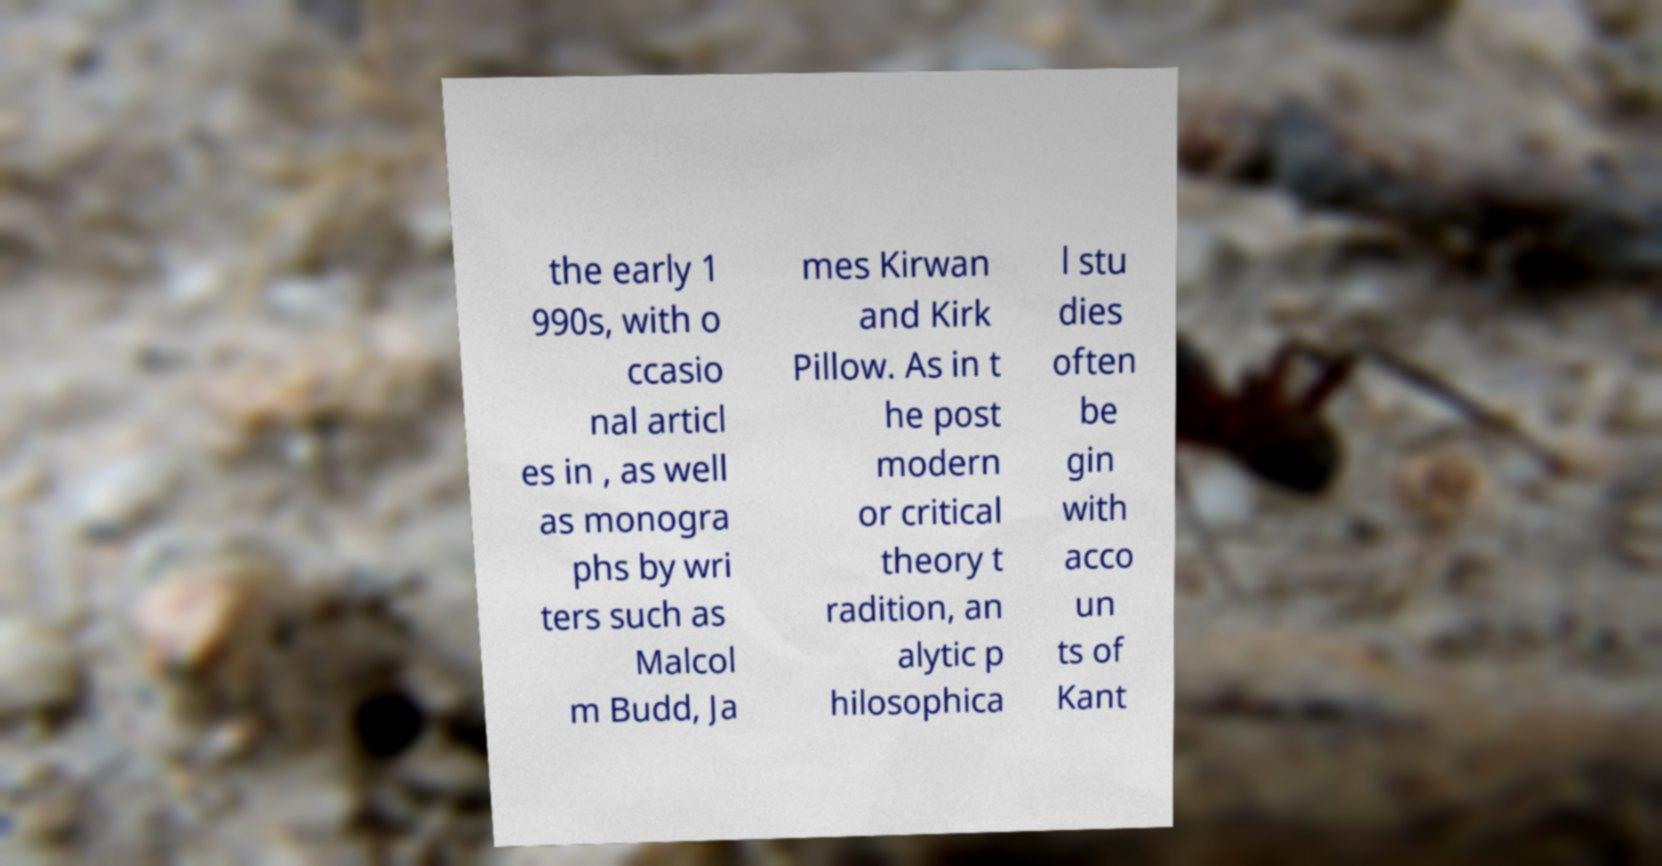Could you extract and type out the text from this image? the early 1 990s, with o ccasio nal articl es in , as well as monogra phs by wri ters such as Malcol m Budd, Ja mes Kirwan and Kirk Pillow. As in t he post modern or critical theory t radition, an alytic p hilosophica l stu dies often be gin with acco un ts of Kant 